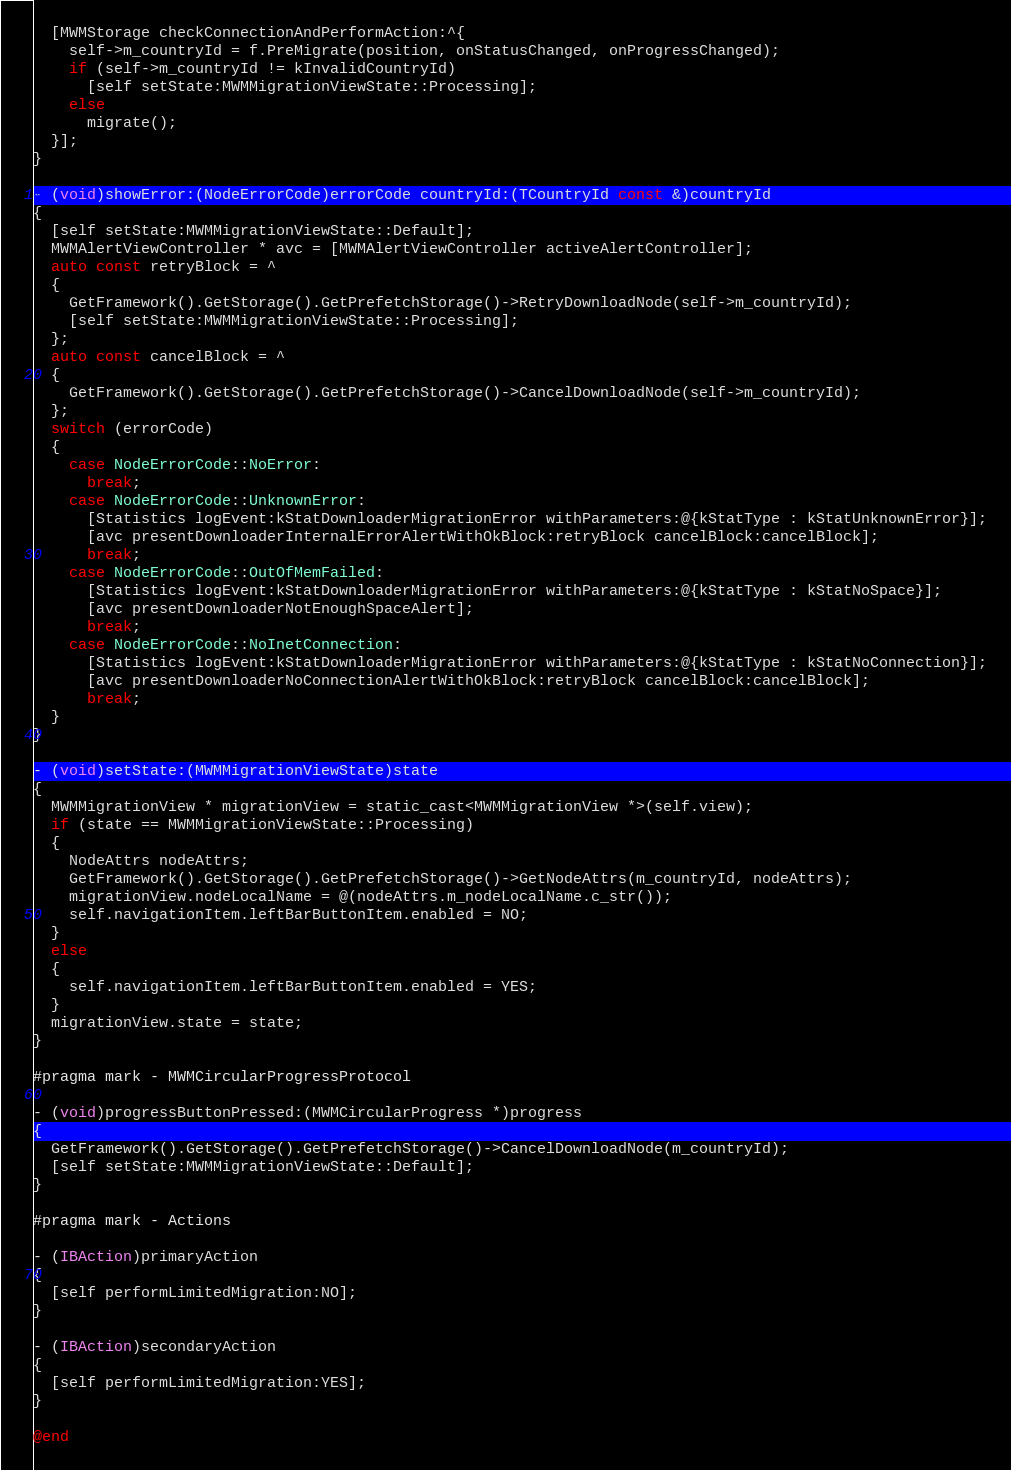<code> <loc_0><loc_0><loc_500><loc_500><_ObjectiveC_>  [MWMStorage checkConnectionAndPerformAction:^{
    self->m_countryId = f.PreMigrate(position, onStatusChanged, onProgressChanged);
    if (self->m_countryId != kInvalidCountryId)
      [self setState:MWMMigrationViewState::Processing];
    else
      migrate();
  }];
}

- (void)showError:(NodeErrorCode)errorCode countryId:(TCountryId const &)countryId
{
  [self setState:MWMMigrationViewState::Default];
  MWMAlertViewController * avc = [MWMAlertViewController activeAlertController];
  auto const retryBlock = ^
  {
    GetFramework().GetStorage().GetPrefetchStorage()->RetryDownloadNode(self->m_countryId);
    [self setState:MWMMigrationViewState::Processing];
  };
  auto const cancelBlock = ^
  {
    GetFramework().GetStorage().GetPrefetchStorage()->CancelDownloadNode(self->m_countryId);
  };
  switch (errorCode)
  {
    case NodeErrorCode::NoError:
      break;
    case NodeErrorCode::UnknownError:
      [Statistics logEvent:kStatDownloaderMigrationError withParameters:@{kStatType : kStatUnknownError}];
      [avc presentDownloaderInternalErrorAlertWithOkBlock:retryBlock cancelBlock:cancelBlock];
      break;
    case NodeErrorCode::OutOfMemFailed:
      [Statistics logEvent:kStatDownloaderMigrationError withParameters:@{kStatType : kStatNoSpace}];
      [avc presentDownloaderNotEnoughSpaceAlert];
      break;
    case NodeErrorCode::NoInetConnection:
      [Statistics logEvent:kStatDownloaderMigrationError withParameters:@{kStatType : kStatNoConnection}];
      [avc presentDownloaderNoConnectionAlertWithOkBlock:retryBlock cancelBlock:cancelBlock];
      break;
  }
}

- (void)setState:(MWMMigrationViewState)state
{
  MWMMigrationView * migrationView = static_cast<MWMMigrationView *>(self.view);
  if (state == MWMMigrationViewState::Processing)
  {
    NodeAttrs nodeAttrs;
    GetFramework().GetStorage().GetPrefetchStorage()->GetNodeAttrs(m_countryId, nodeAttrs);
    migrationView.nodeLocalName = @(nodeAttrs.m_nodeLocalName.c_str());
    self.navigationItem.leftBarButtonItem.enabled = NO;
  }
  else
  {
    self.navigationItem.leftBarButtonItem.enabled = YES;
  }
  migrationView.state = state;
}

#pragma mark - MWMCircularProgressProtocol

- (void)progressButtonPressed:(MWMCircularProgress *)progress
{
  GetFramework().GetStorage().GetPrefetchStorage()->CancelDownloadNode(m_countryId);
  [self setState:MWMMigrationViewState::Default];
}

#pragma mark - Actions

- (IBAction)primaryAction
{
  [self performLimitedMigration:NO];
}

- (IBAction)secondaryAction
{
  [self performLimitedMigration:YES];
}

@end
</code> 